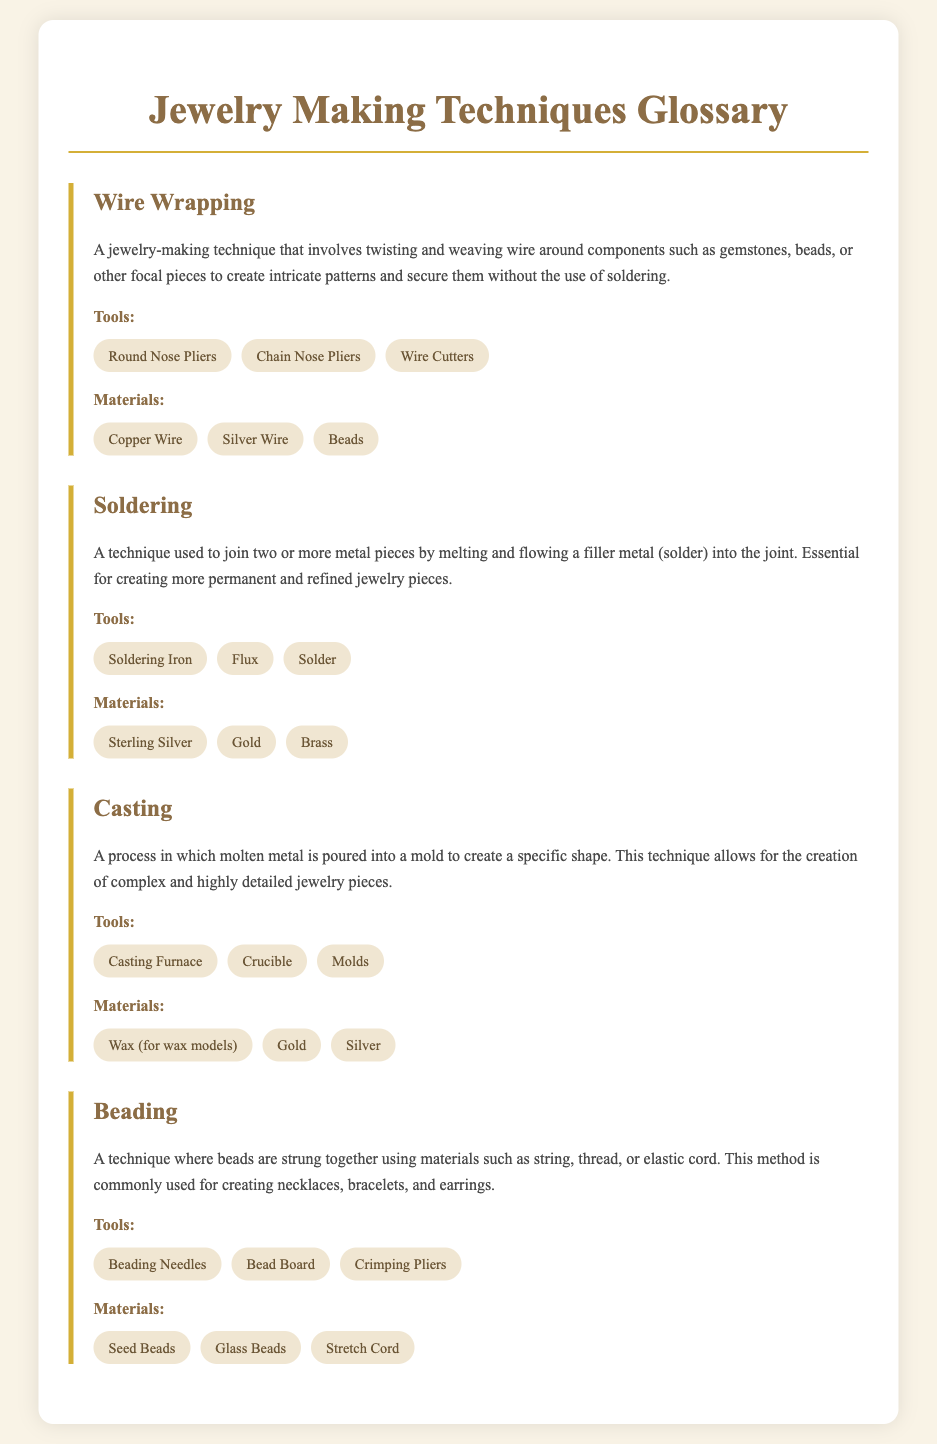What is the first technique listed? The first technique in the document is "Wire Wrapping," highlighted under the term section.
Answer: Wire Wrapping How many tools are listed for Soldering? The section for Soldering mentions three tools used in this technique.
Answer: 3 Which materials are used in Casting? The materials for Casting include Wax (for wax models), Gold, and Silver, as provided in the document.
Answer: Wax (for wax models), Gold, Silver What is the main purpose of Beading? The purpose of Beading, as described, is to string beads together to create items like necklaces, bracelets, and earrings.
Answer: Creating necklaces, bracelets, earrings Which tool is common in both Wire Wrapping and Beading? Both techniques mention using specific types of pliers as tools in their processes.
Answer: Pliers 